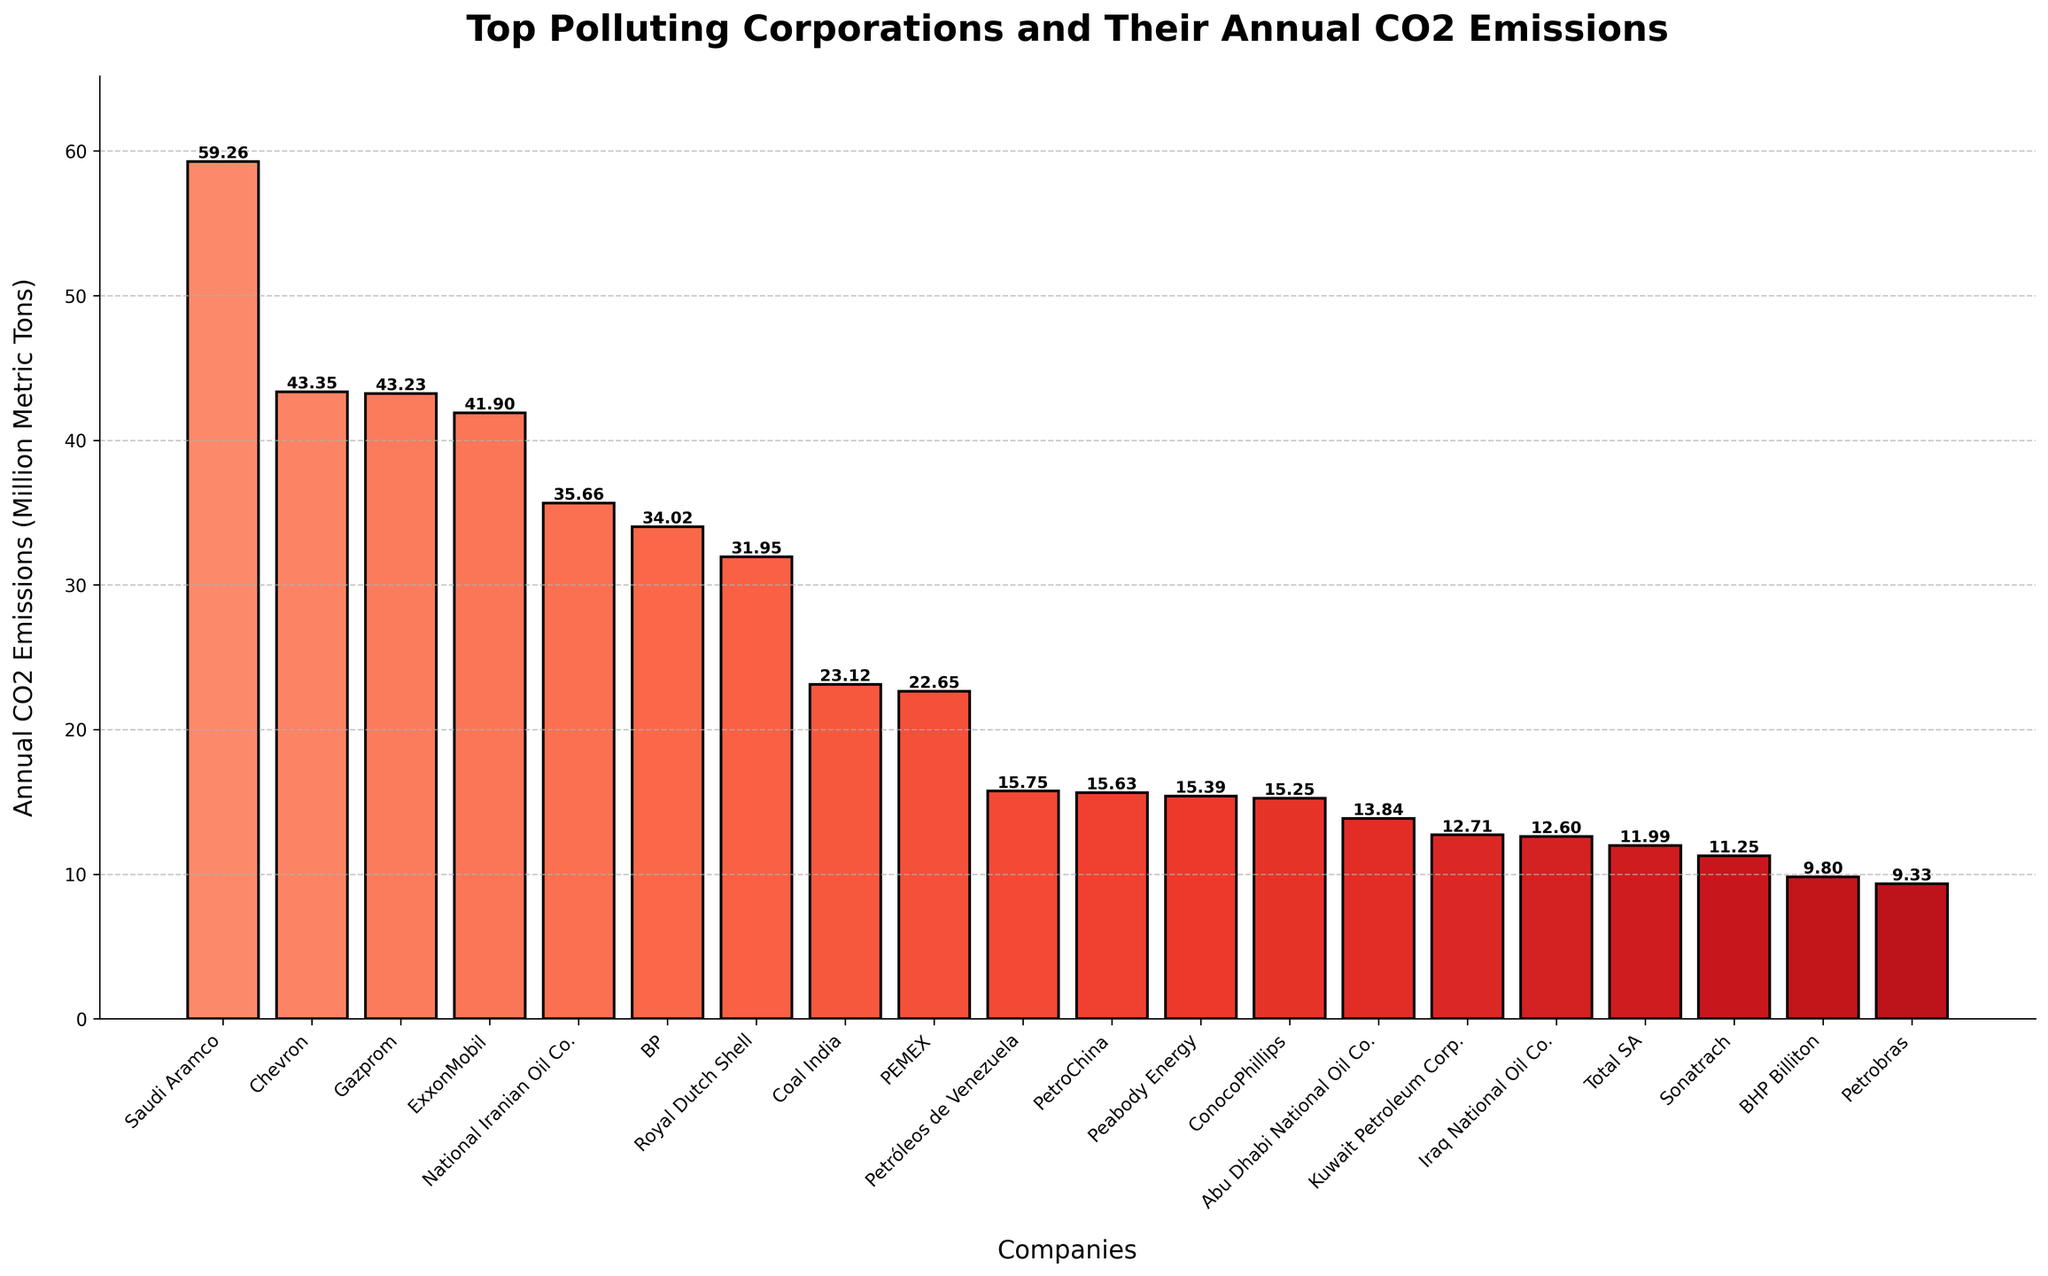What's the difference in annual CO2 emissions between Saudi Aramco and ExxonMobil? Look at the heights of the bars for Saudi Aramco and ExxonMobil. Saudi Aramco generates 59.26 million metric tons of CO2, while ExxonMobil generates 41.90 million metric tons. The difference can be calculated as 59.26 - 41.90.
Answer: 17.36 million metric tons Which company has lower emissions, Royal Dutch Shell or PetroChina? Locate the bars for Royal Dutch Shell and PetroChina. Royal Dutch Shell's emissions are 31.95 million metric tons, whereas PetroChina's emissions are 15.63 million metric tons. Since 15.63 is less than 31.95, PetroChina has lower emissions.
Answer: PetroChina What is the total annual CO2 emissions of BP, ConocoPhillips, and BHP Billiton? Identify the emissions for each of the three companies: BP (34.02), ConocoPhillips (15.25), and BHP Billiton (9.80). Sum these values: 34.02 + 15.25 + 9.80.
Answer: 59.07 million metric tons Which company is the top polluter? Look at the highest bar in the figure, which represents the company with the largest emissions. The highest bar corresponds to Saudi Aramco with 59.26 million metric tons.
Answer: Saudi Aramco How many companies have emissions greater than 30 million metric tons? Count the bars with heights representing emissions greater than 30 million metric tons. These companies are Saudi Aramco, Chevron, Gazprom, ExxonMobil, National Iranian Oil Co., BP, and Royal Dutch Shell.
Answer: 7 companies How does the annual CO2 emissions of BP compare with Chevron? Compare the heights of the bars representing BP and Chevron. BP emits 34.02 million metric tons, whereas Chevron emits 43.35 million metric tons. Chevron's emissions are greater than BP's.
Answer: Chevron emits more What is the combined annual CO2 emissions of the three lowest-emitting companies? Identify the emissions of the three companies with the smallest bars: Petrobras (9.33), BHP Billiton (9.80), and Sonatrach (11.25). Sum these values: 9.33 + 9.80 + 11.25.
Answer: 30.38 million metric tons Among the companies listed, which have emissions less than 20 million metric tons? Find and list the bars representing companies with emissions less than 20 million metric tons. These companies are Petróleos de Venezuela (15.75), PetroChina (15.63), Peabody Energy (15.39), ConocoPhillips (15.25), Abu Dhabi National Oil Co. (13.84), Kuwait Petroleum Corp. (12.71), Iraq National Oil Co. (12.60), Total SA (11.99), Sonatrach (11.25), BHP Billiton (9.80), and Petrobras (9.33).
Answer: 11 companies What is the average annual CO2 emissions of Saudi Aramco, Gazprom, and Coal India? First, identify the emissions of Saudi Aramco (59.26), Gazprom (43.23), and Coal India (23.12). Sum these values: 59.26 + 43.23 + 23.12, then divide by 3.
Answer: 41.87 million metric tons How much greater are the emissions of Chevron compared to Total SA? Look at the emissions of Chevron (43.35) and Total SA (11.99). Calculate the difference: 43.35 - 11.99.
Answer: 31.36 million metric tons 